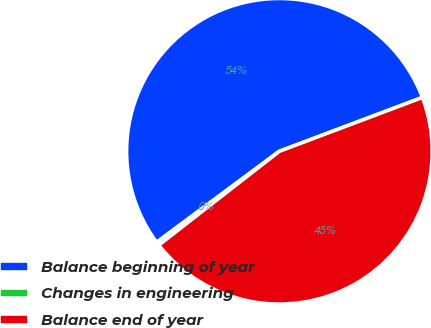<chart> <loc_0><loc_0><loc_500><loc_500><pie_chart><fcel>Balance beginning of year<fcel>Changes in engineering<fcel>Balance end of year<nl><fcel>54.42%<fcel>0.37%<fcel>45.2%<nl></chart> 